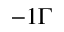Convert formula to latex. <formula><loc_0><loc_0><loc_500><loc_500>- 1 \Gamma</formula> 